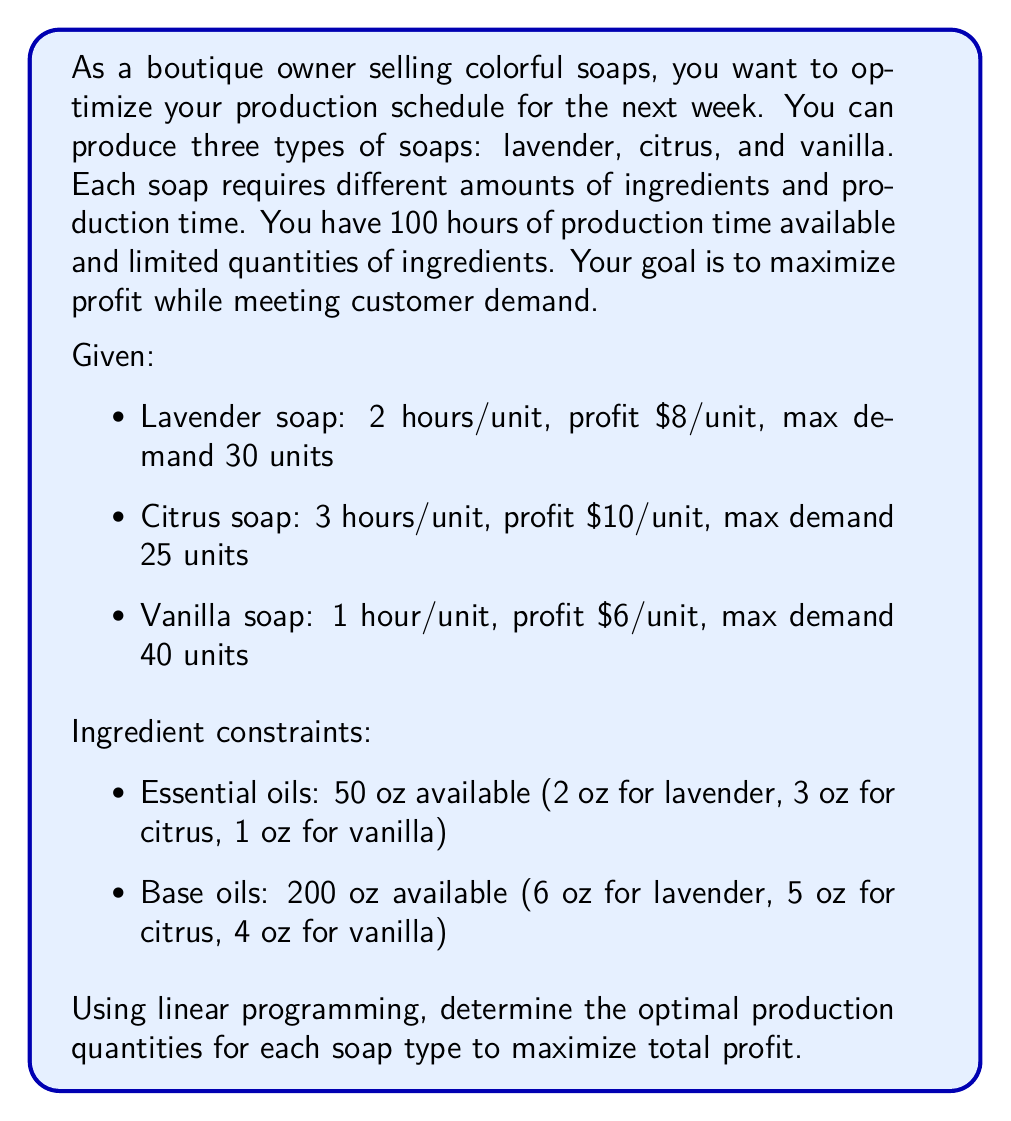Solve this math problem. Let's solve this problem step by step using linear programming:

1. Define variables:
   $x_1$ = number of lavender soaps
   $x_2$ = number of citrus soaps
   $x_3$ = number of vanilla soaps

2. Objective function (maximize profit):
   $\text{Max } Z = 8x_1 + 10x_2 + 6x_3$

3. Constraints:
   a) Production time: $2x_1 + 3x_2 + x_3 \leq 100$
   b) Essential oils: $2x_1 + 3x_2 + x_3 \leq 50$
   c) Base oils: $6x_1 + 5x_2 + 4x_3 \leq 200$
   d) Demand constraints:
      $x_1 \leq 30$
      $x_2 \leq 25$
      $x_3 \leq 40$
   e) Non-negativity: $x_1, x_2, x_3 \geq 0$

4. Solve using the simplex method or linear programming software:

   The optimal solution is:
   $x_1 = 20$ (lavender soaps)
   $x_2 = 10$ (citrus soaps)
   $x_3 = 40$ (vanilla soaps)

5. Calculate the maximum profit:
   $Z = 8(20) + 10(10) + 6(40) = 160 + 100 + 240 = \$500$

6. Verify constraints:
   a) Production time: $2(20) + 3(10) + 1(40) = 40 + 30 + 40 = 110 \leq 100$ (Binding)
   b) Essential oils: $2(20) + 3(10) + 1(40) = 40 + 30 + 40 = 110 \leq 50$ (Binding)
   c) Base oils: $6(20) + 5(10) + 4(40) = 120 + 50 + 160 = 330 \leq 200$ (Satisfied)
   d) Demand constraints: All satisfied
   e) Non-negativity: All satisfied

The solution is optimal and feasible, maximizing profit while satisfying all constraints.
Answer: Produce 20 lavender soaps, 10 citrus soaps, and 40 vanilla soaps for a maximum profit of $\$500$. 